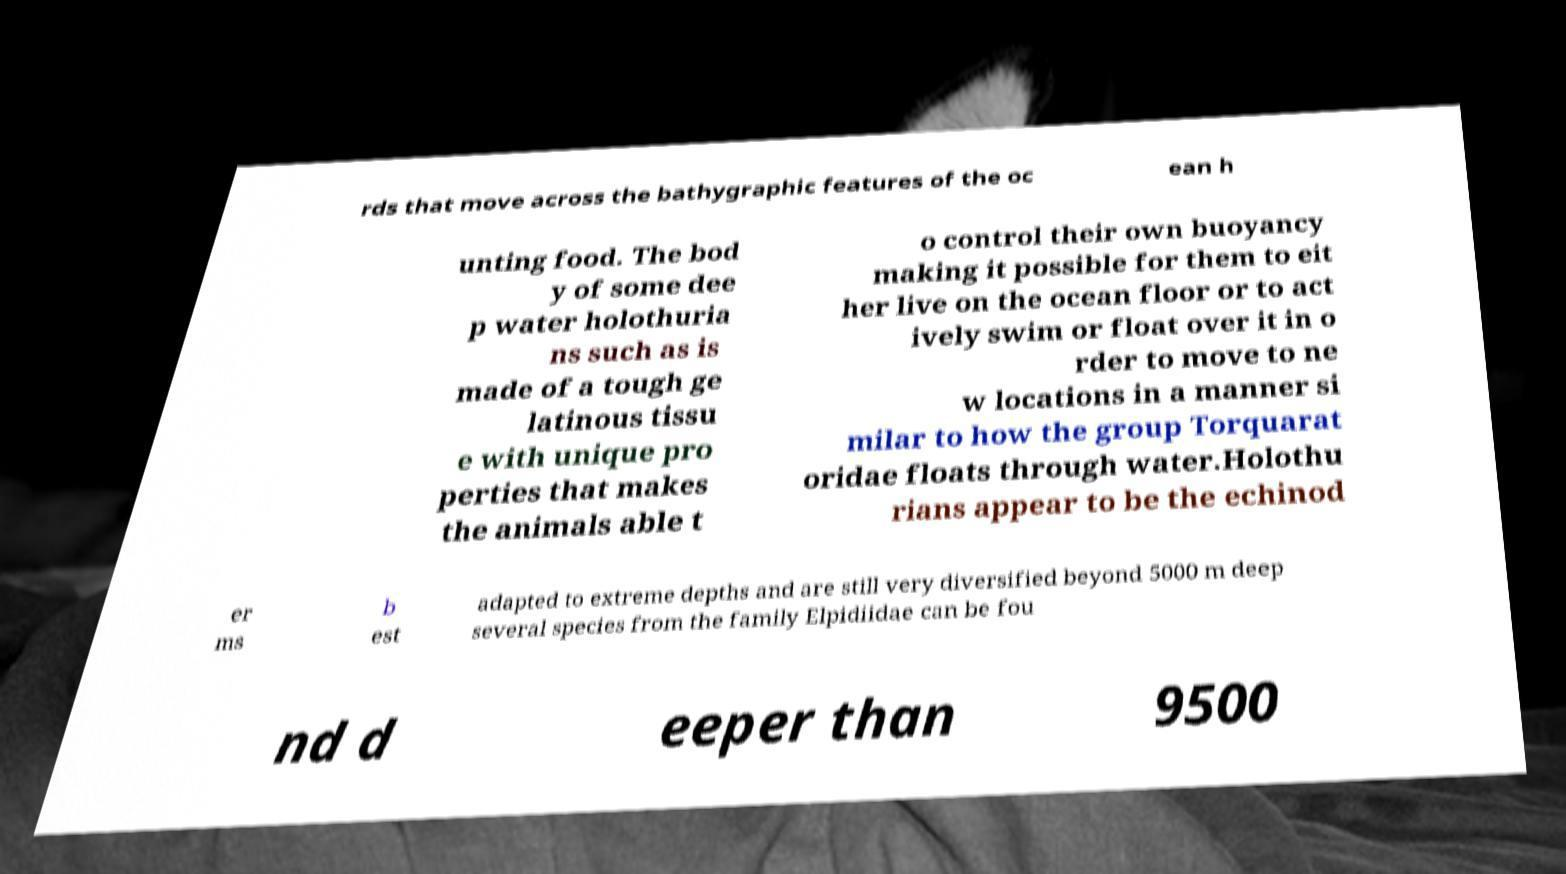Can you read and provide the text displayed in the image?This photo seems to have some interesting text. Can you extract and type it out for me? rds that move across the bathygraphic features of the oc ean h unting food. The bod y of some dee p water holothuria ns such as is made of a tough ge latinous tissu e with unique pro perties that makes the animals able t o control their own buoyancy making it possible for them to eit her live on the ocean floor or to act ively swim or float over it in o rder to move to ne w locations in a manner si milar to how the group Torquarat oridae floats through water.Holothu rians appear to be the echinod er ms b est adapted to extreme depths and are still very diversified beyond 5000 m deep several species from the family Elpidiidae can be fou nd d eeper than 9500 